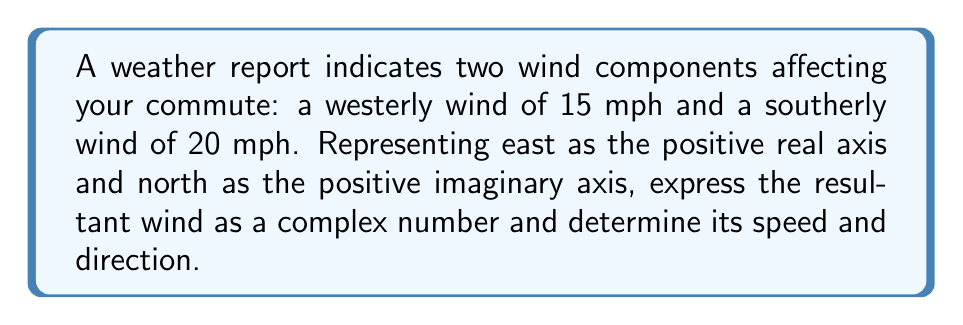Give your solution to this math problem. 1) Let's represent the wind components as complex numbers:
   Westerly wind: $-15 + 0i$ (negative real part as it's westerly)
   Southerly wind: $0 - 20i$ (negative imaginary part as it's southerly)

2) Add the complex numbers to get the resultant wind:
   $(-15 + 0i) + (0 - 20i) = -15 - 20i$

3) To find the speed, calculate the magnitude of the complex number:
   $|\text{speed}| = \sqrt{(-15)^2 + (-20)^2} = \sqrt{225 + 400} = \sqrt{625} = 25$ mph

4) To find the direction, calculate the argument of the complex number:
   $\theta = \tan^{-1}(\frac{\text{Im}}{\text{Re}}) = \tan^{-1}(\frac{-20}{-15}) = \tan^{-1}(\frac{4}{3})$

5) Convert to degrees:
   $\theta = \tan^{-1}(\frac{4}{3}) \approx 53.13°$

6) Adjust for the third quadrant:
   $53.13° + 180° = 233.13°$

This represents 233.13° clockwise from north, or equivalently, the wind is coming from 233.13° (roughly WSW).
Answer: $-15 - 20i$, 25 mph from 233.13° 